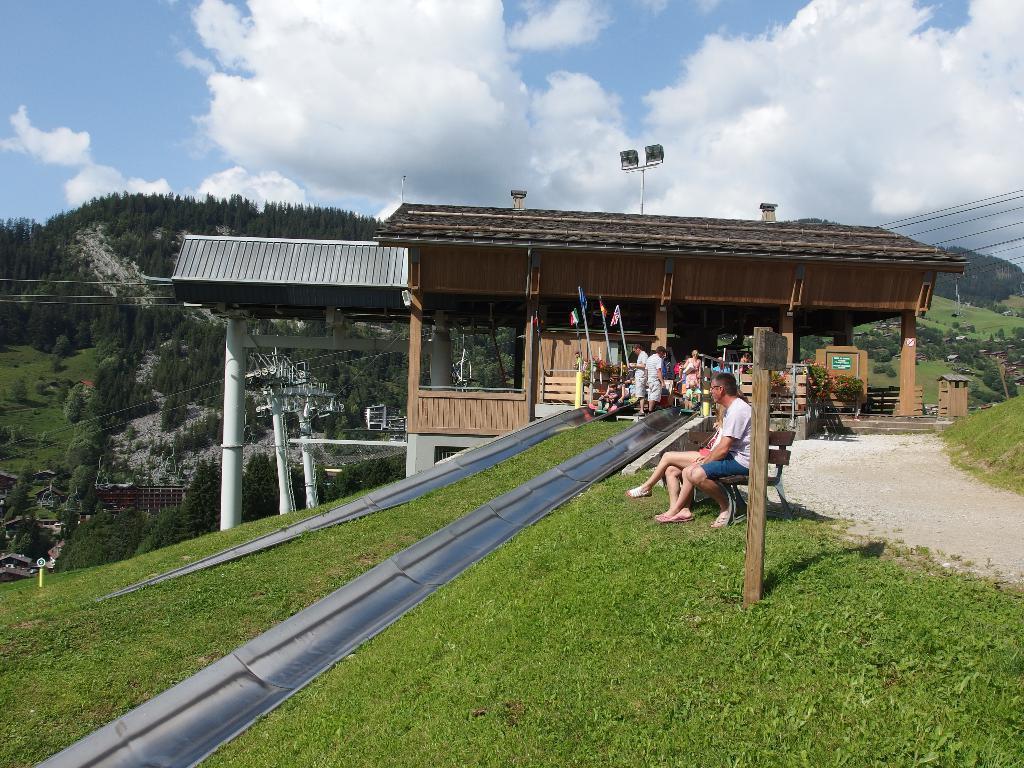Please provide a concise description of this image. In this image I can see some grass, the black colored path, few persons sitting on benches, a wooden pole, few pillars, few wires and in the background I can see few mountains, few trees and the sky. 